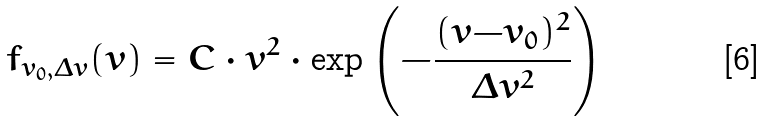<formula> <loc_0><loc_0><loc_500><loc_500>f _ { v _ { 0 } , \Delta v } ( v ) = C \cdot v ^ { 2 } \cdot \exp \left ( - \frac { ( v { - } v _ { 0 } ) ^ { 2 } } { \Delta v ^ { 2 } } \right )</formula> 